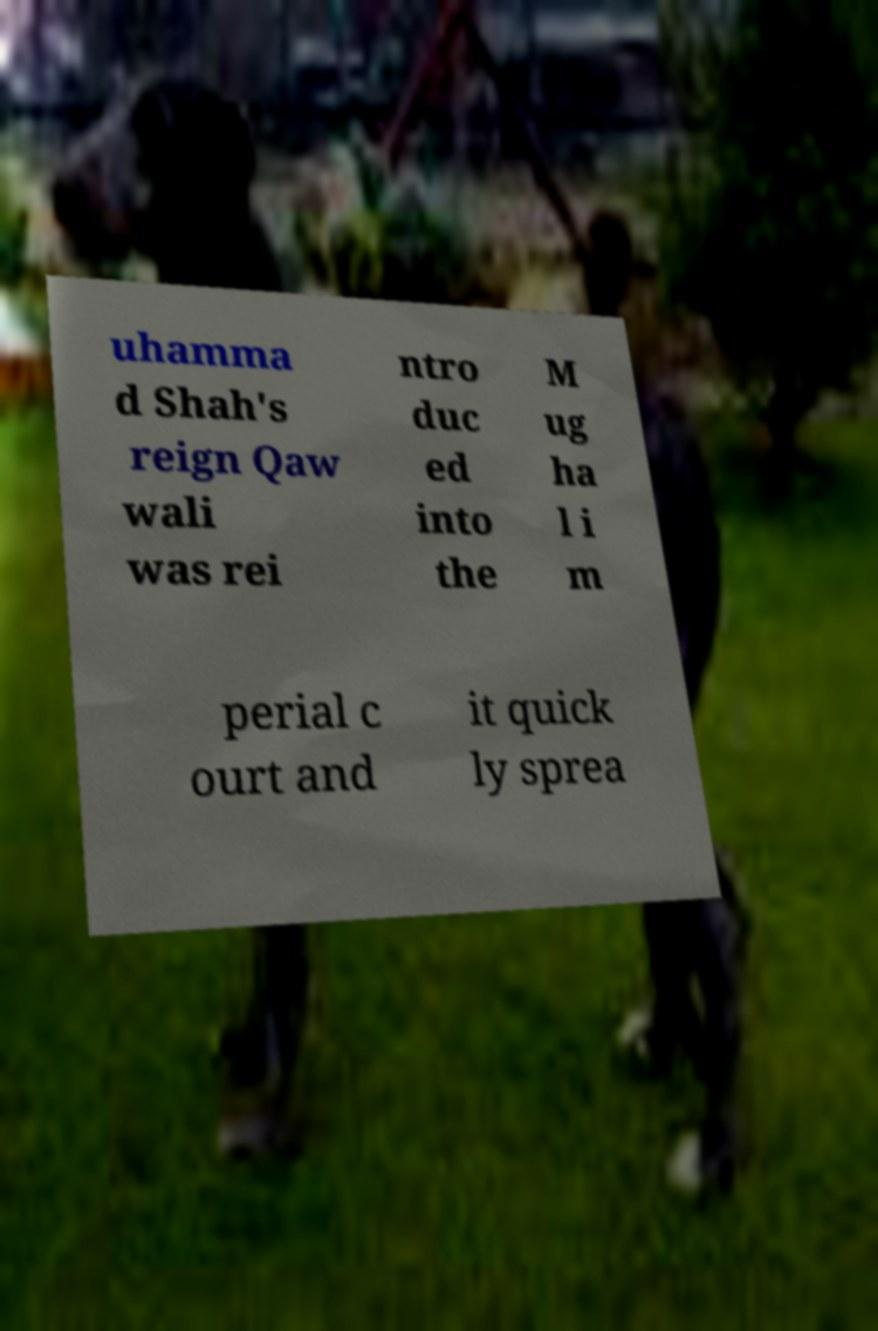Please read and relay the text visible in this image. What does it say? uhamma d Shah's reign Qaw wali was rei ntro duc ed into the M ug ha l i m perial c ourt and it quick ly sprea 